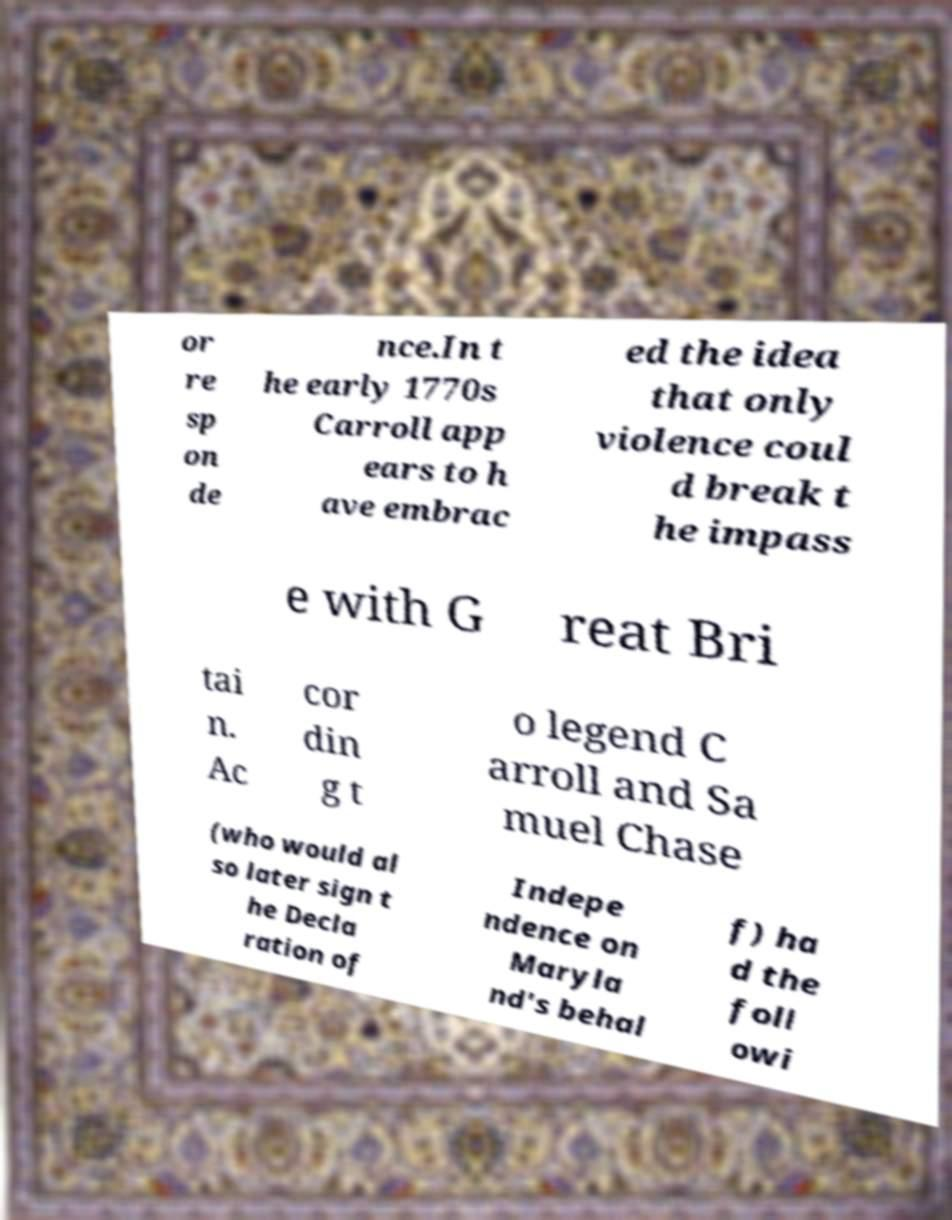There's text embedded in this image that I need extracted. Can you transcribe it verbatim? or re sp on de nce.In t he early 1770s Carroll app ears to h ave embrac ed the idea that only violence coul d break t he impass e with G reat Bri tai n. Ac cor din g t o legend C arroll and Sa muel Chase (who would al so later sign t he Decla ration of Indepe ndence on Maryla nd's behal f) ha d the foll owi 